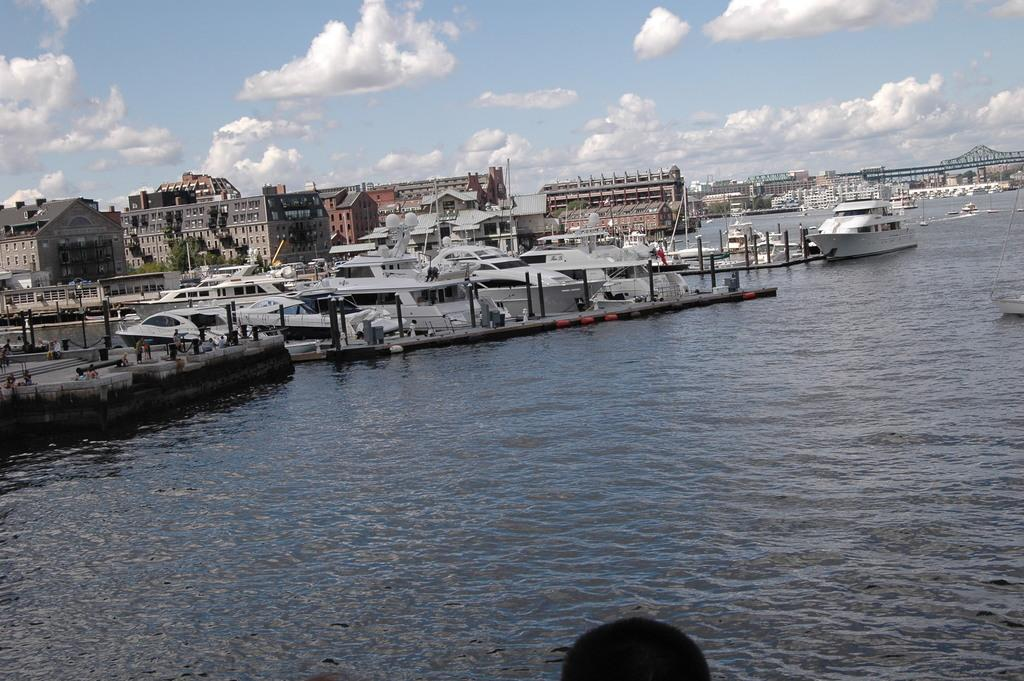What is on the water in the image? There are boats on the water in the image. What else can be seen in the image besides the boats? There are buildings, trees, and a bridge on the right side of the image. What is visible in the background of the image? The sky is visible in the background of the image. What appliance is being used to generate profit in the image? There is no appliance or mention of profit in the image; it features boats on the water, buildings, trees, a bridge, and the sky. 